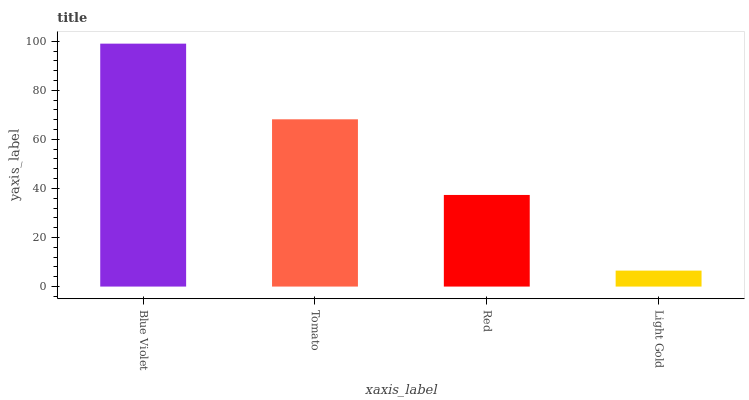Is Light Gold the minimum?
Answer yes or no. Yes. Is Blue Violet the maximum?
Answer yes or no. Yes. Is Tomato the minimum?
Answer yes or no. No. Is Tomato the maximum?
Answer yes or no. No. Is Blue Violet greater than Tomato?
Answer yes or no. Yes. Is Tomato less than Blue Violet?
Answer yes or no. Yes. Is Tomato greater than Blue Violet?
Answer yes or no. No. Is Blue Violet less than Tomato?
Answer yes or no. No. Is Tomato the high median?
Answer yes or no. Yes. Is Red the low median?
Answer yes or no. Yes. Is Blue Violet the high median?
Answer yes or no. No. Is Light Gold the low median?
Answer yes or no. No. 